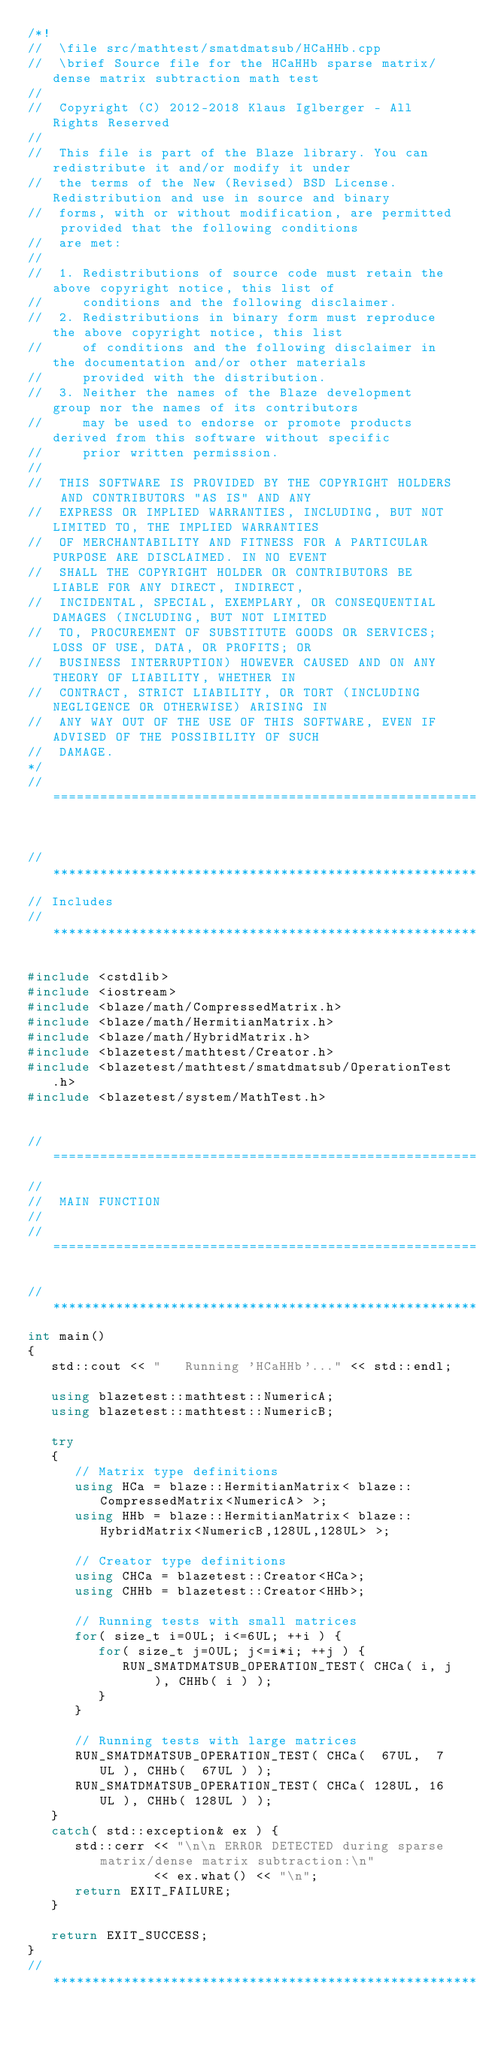<code> <loc_0><loc_0><loc_500><loc_500><_C++_>/*!
//  \file src/mathtest/smatdmatsub/HCaHHb.cpp
//  \brief Source file for the HCaHHb sparse matrix/dense matrix subtraction math test
//
//  Copyright (C) 2012-2018 Klaus Iglberger - All Rights Reserved
//
//  This file is part of the Blaze library. You can redistribute it and/or modify it under
//  the terms of the New (Revised) BSD License. Redistribution and use in source and binary
//  forms, with or without modification, are permitted provided that the following conditions
//  are met:
//
//  1. Redistributions of source code must retain the above copyright notice, this list of
//     conditions and the following disclaimer.
//  2. Redistributions in binary form must reproduce the above copyright notice, this list
//     of conditions and the following disclaimer in the documentation and/or other materials
//     provided with the distribution.
//  3. Neither the names of the Blaze development group nor the names of its contributors
//     may be used to endorse or promote products derived from this software without specific
//     prior written permission.
//
//  THIS SOFTWARE IS PROVIDED BY THE COPYRIGHT HOLDERS AND CONTRIBUTORS "AS IS" AND ANY
//  EXPRESS OR IMPLIED WARRANTIES, INCLUDING, BUT NOT LIMITED TO, THE IMPLIED WARRANTIES
//  OF MERCHANTABILITY AND FITNESS FOR A PARTICULAR PURPOSE ARE DISCLAIMED. IN NO EVENT
//  SHALL THE COPYRIGHT HOLDER OR CONTRIBUTORS BE LIABLE FOR ANY DIRECT, INDIRECT,
//  INCIDENTAL, SPECIAL, EXEMPLARY, OR CONSEQUENTIAL DAMAGES (INCLUDING, BUT NOT LIMITED
//  TO, PROCUREMENT OF SUBSTITUTE GOODS OR SERVICES; LOSS OF USE, DATA, OR PROFITS; OR
//  BUSINESS INTERRUPTION) HOWEVER CAUSED AND ON ANY THEORY OF LIABILITY, WHETHER IN
//  CONTRACT, STRICT LIABILITY, OR TORT (INCLUDING NEGLIGENCE OR OTHERWISE) ARISING IN
//  ANY WAY OUT OF THE USE OF THIS SOFTWARE, EVEN IF ADVISED OF THE POSSIBILITY OF SUCH
//  DAMAGE.
*/
//=================================================================================================


//*************************************************************************************************
// Includes
//*************************************************************************************************

#include <cstdlib>
#include <iostream>
#include <blaze/math/CompressedMatrix.h>
#include <blaze/math/HermitianMatrix.h>
#include <blaze/math/HybridMatrix.h>
#include <blazetest/mathtest/Creator.h>
#include <blazetest/mathtest/smatdmatsub/OperationTest.h>
#include <blazetest/system/MathTest.h>


//=================================================================================================
//
//  MAIN FUNCTION
//
//=================================================================================================

//*************************************************************************************************
int main()
{
   std::cout << "   Running 'HCaHHb'..." << std::endl;

   using blazetest::mathtest::NumericA;
   using blazetest::mathtest::NumericB;

   try
   {
      // Matrix type definitions
      using HCa = blaze::HermitianMatrix< blaze::CompressedMatrix<NumericA> >;
      using HHb = blaze::HermitianMatrix< blaze::HybridMatrix<NumericB,128UL,128UL> >;

      // Creator type definitions
      using CHCa = blazetest::Creator<HCa>;
      using CHHb = blazetest::Creator<HHb>;

      // Running tests with small matrices
      for( size_t i=0UL; i<=6UL; ++i ) {
         for( size_t j=0UL; j<=i*i; ++j ) {
            RUN_SMATDMATSUB_OPERATION_TEST( CHCa( i, j ), CHHb( i ) );
         }
      }

      // Running tests with large matrices
      RUN_SMATDMATSUB_OPERATION_TEST( CHCa(  67UL,  7UL ), CHHb(  67UL ) );
      RUN_SMATDMATSUB_OPERATION_TEST( CHCa( 128UL, 16UL ), CHHb( 128UL ) );
   }
   catch( std::exception& ex ) {
      std::cerr << "\n\n ERROR DETECTED during sparse matrix/dense matrix subtraction:\n"
                << ex.what() << "\n";
      return EXIT_FAILURE;
   }

   return EXIT_SUCCESS;
}
//*************************************************************************************************
</code> 